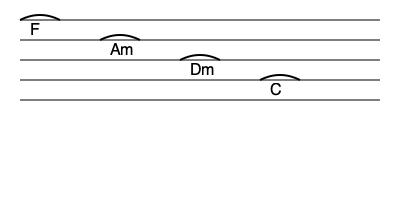Analyze the chord progression shown in the music staff diagram for T-ara's "Roly-Poly". What musical function does the progression serve, and how does it contribute to the song's catchy nature? To analyze the chord progression of T-ara's "Roly-Poly", let's break it down step-by-step:

1. The chord progression shown is: F - Am - Dm - C

2. This progression is in the key of F major, as F is the tonic (I) chord.

3. The roman numeral analysis of this progression would be:
   F (I) - Am (iii) - Dm (vi) - C (V)

4. This progression serves several musical functions:

   a) It establishes the key of F major with the opening F chord.
   
   b) The Am (iii) chord provides a minor contrast, adding emotional depth.
   
   c) The Dm (vi) chord further emphasizes the minor quality, creating tension.
   
   d) The C (V) chord serves as the dominant, creating a strong pull back to the tonic F.

5. This progression is an example of a "circle progression" or "descending fifths sequence":
   
   F → C → G → D → A → E → B → F
   (F and Am share G, Am and Dm share C, Dm and C share F)

6. The catchy nature of this progression comes from:

   a) Its circular motion, which creates a sense of continuity and repeatability.
   
   b) The balance between major and minor chords, providing tonal variety.
   
   c) The strong dominant-tonic relationship between C and F, giving a satisfying resolution.

7. In pop music context, this progression is often associated with a "retro" or "disco" sound, which aligns with the overall style of "Roly-Poly".

This analysis demonstrates how the chord progression contributes to the song's memorable and danceable quality, a hallmark of T-ara's music and particularly evident in "Roly-Poly".
Answer: Circle progression (I-iii-vi-V) creating continuity and tonal variety with a strong dominant-tonic resolution, contributing to a catchy, retro disco sound. 